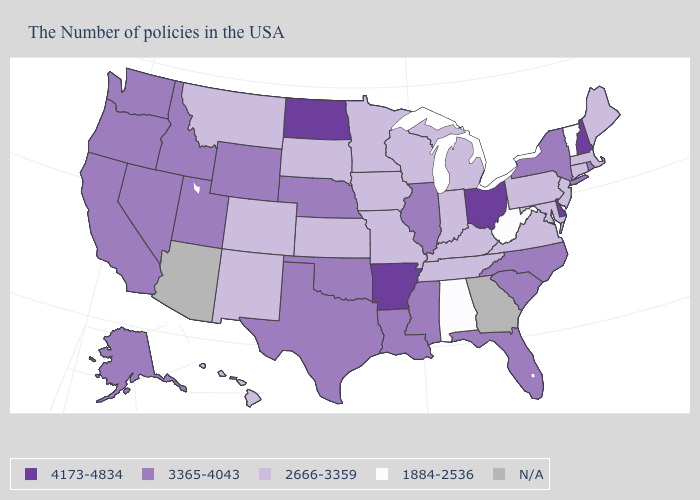What is the value of Kentucky?
Concise answer only. 2666-3359. Name the states that have a value in the range 1884-2536?
Be succinct. Vermont, West Virginia, Alabama. Does the map have missing data?
Give a very brief answer. Yes. What is the value of Oregon?
Write a very short answer. 3365-4043. Name the states that have a value in the range 1884-2536?
Keep it brief. Vermont, West Virginia, Alabama. What is the value of South Dakota?
Keep it brief. 2666-3359. Name the states that have a value in the range 2666-3359?
Give a very brief answer. Maine, Massachusetts, Connecticut, New Jersey, Maryland, Pennsylvania, Virginia, Michigan, Kentucky, Indiana, Tennessee, Wisconsin, Missouri, Minnesota, Iowa, Kansas, South Dakota, Colorado, New Mexico, Montana, Hawaii. What is the lowest value in the West?
Write a very short answer. 2666-3359. What is the value of South Carolina?
Concise answer only. 3365-4043. Name the states that have a value in the range 3365-4043?
Concise answer only. Rhode Island, New York, North Carolina, South Carolina, Florida, Illinois, Mississippi, Louisiana, Nebraska, Oklahoma, Texas, Wyoming, Utah, Idaho, Nevada, California, Washington, Oregon, Alaska. Name the states that have a value in the range 4173-4834?
Answer briefly. New Hampshire, Delaware, Ohio, Arkansas, North Dakota. Among the states that border Georgia , which have the highest value?
Be succinct. North Carolina, South Carolina, Florida. 